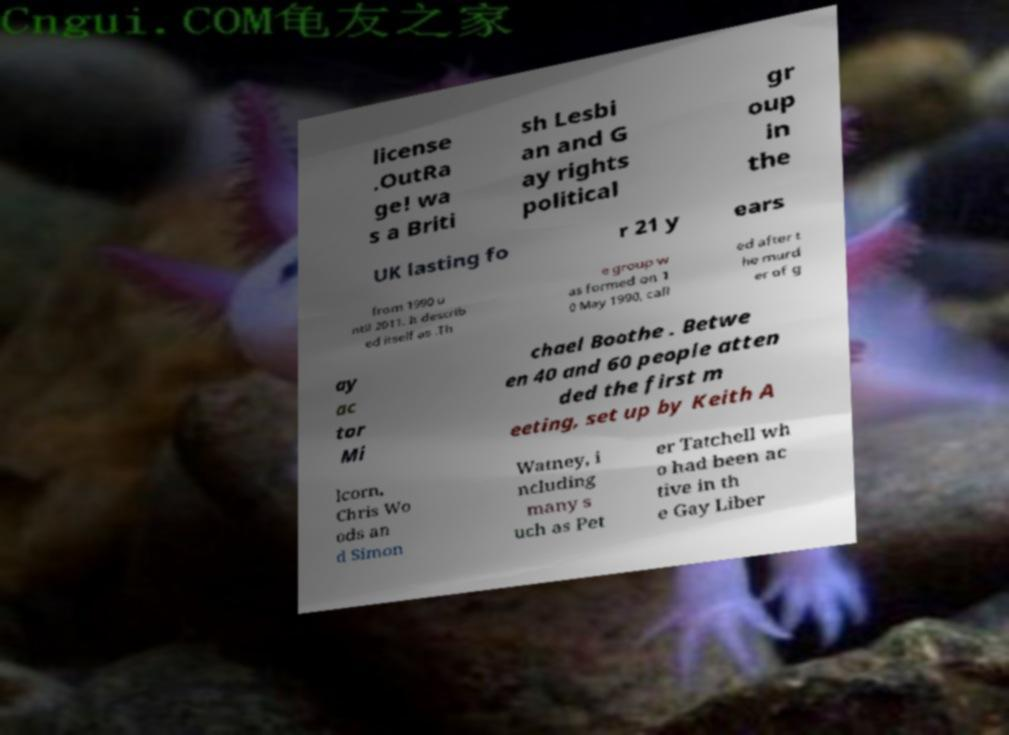Please identify and transcribe the text found in this image. license .OutRa ge! wa s a Briti sh Lesbi an and G ay rights political gr oup in the UK lasting fo r 21 y ears from 1990 u ntil 2011. It describ ed itself as .Th e group w as formed on 1 0 May 1990, call ed after t he murd er of g ay ac tor Mi chael Boothe . Betwe en 40 and 60 people atten ded the first m eeting, set up by Keith A lcorn, Chris Wo ods an d Simon Watney, i ncluding many s uch as Pet er Tatchell wh o had been ac tive in th e Gay Liber 